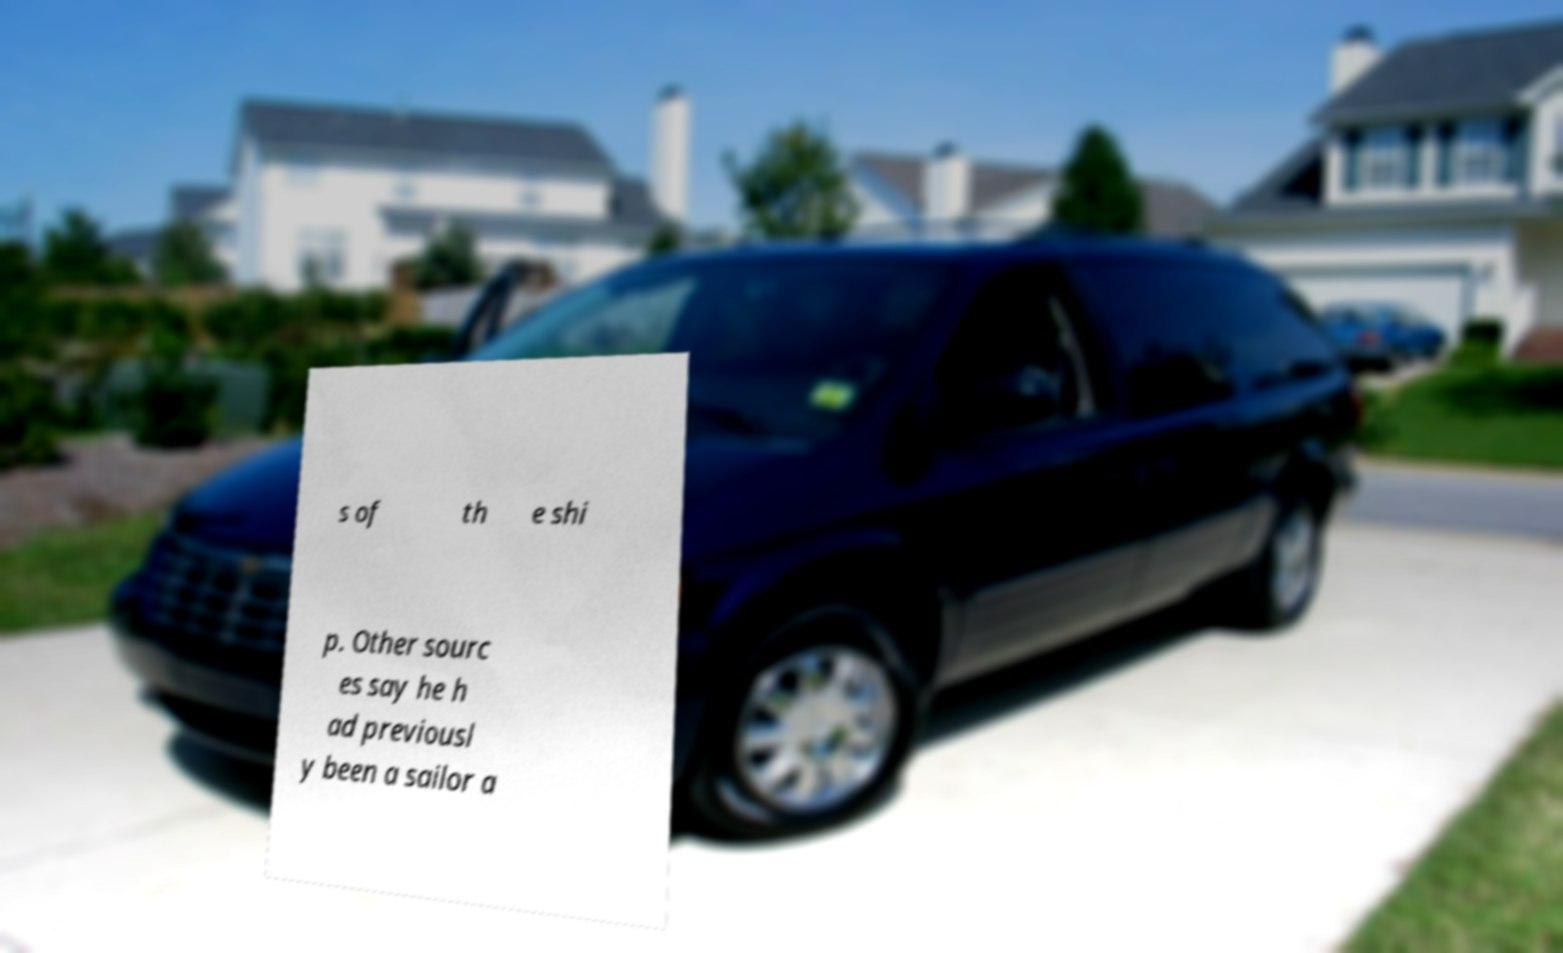Can you accurately transcribe the text from the provided image for me? s of th e shi p. Other sourc es say he h ad previousl y been a sailor a 